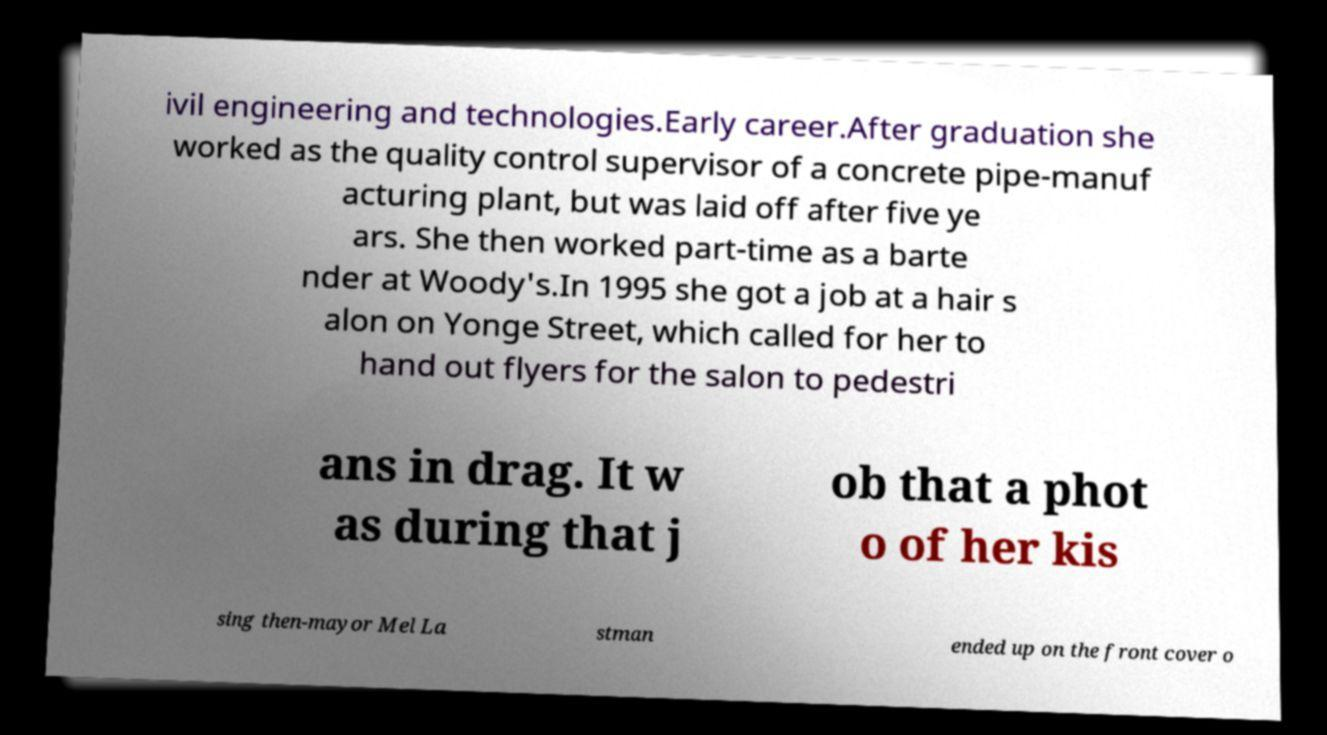Can you accurately transcribe the text from the provided image for me? ivil engineering and technologies.Early career.After graduation she worked as the quality control supervisor of a concrete pipe-manuf acturing plant, but was laid off after five ye ars. She then worked part-time as a barte nder at Woody's.In 1995 she got a job at a hair s alon on Yonge Street, which called for her to hand out flyers for the salon to pedestri ans in drag. It w as during that j ob that a phot o of her kis sing then-mayor Mel La stman ended up on the front cover o 